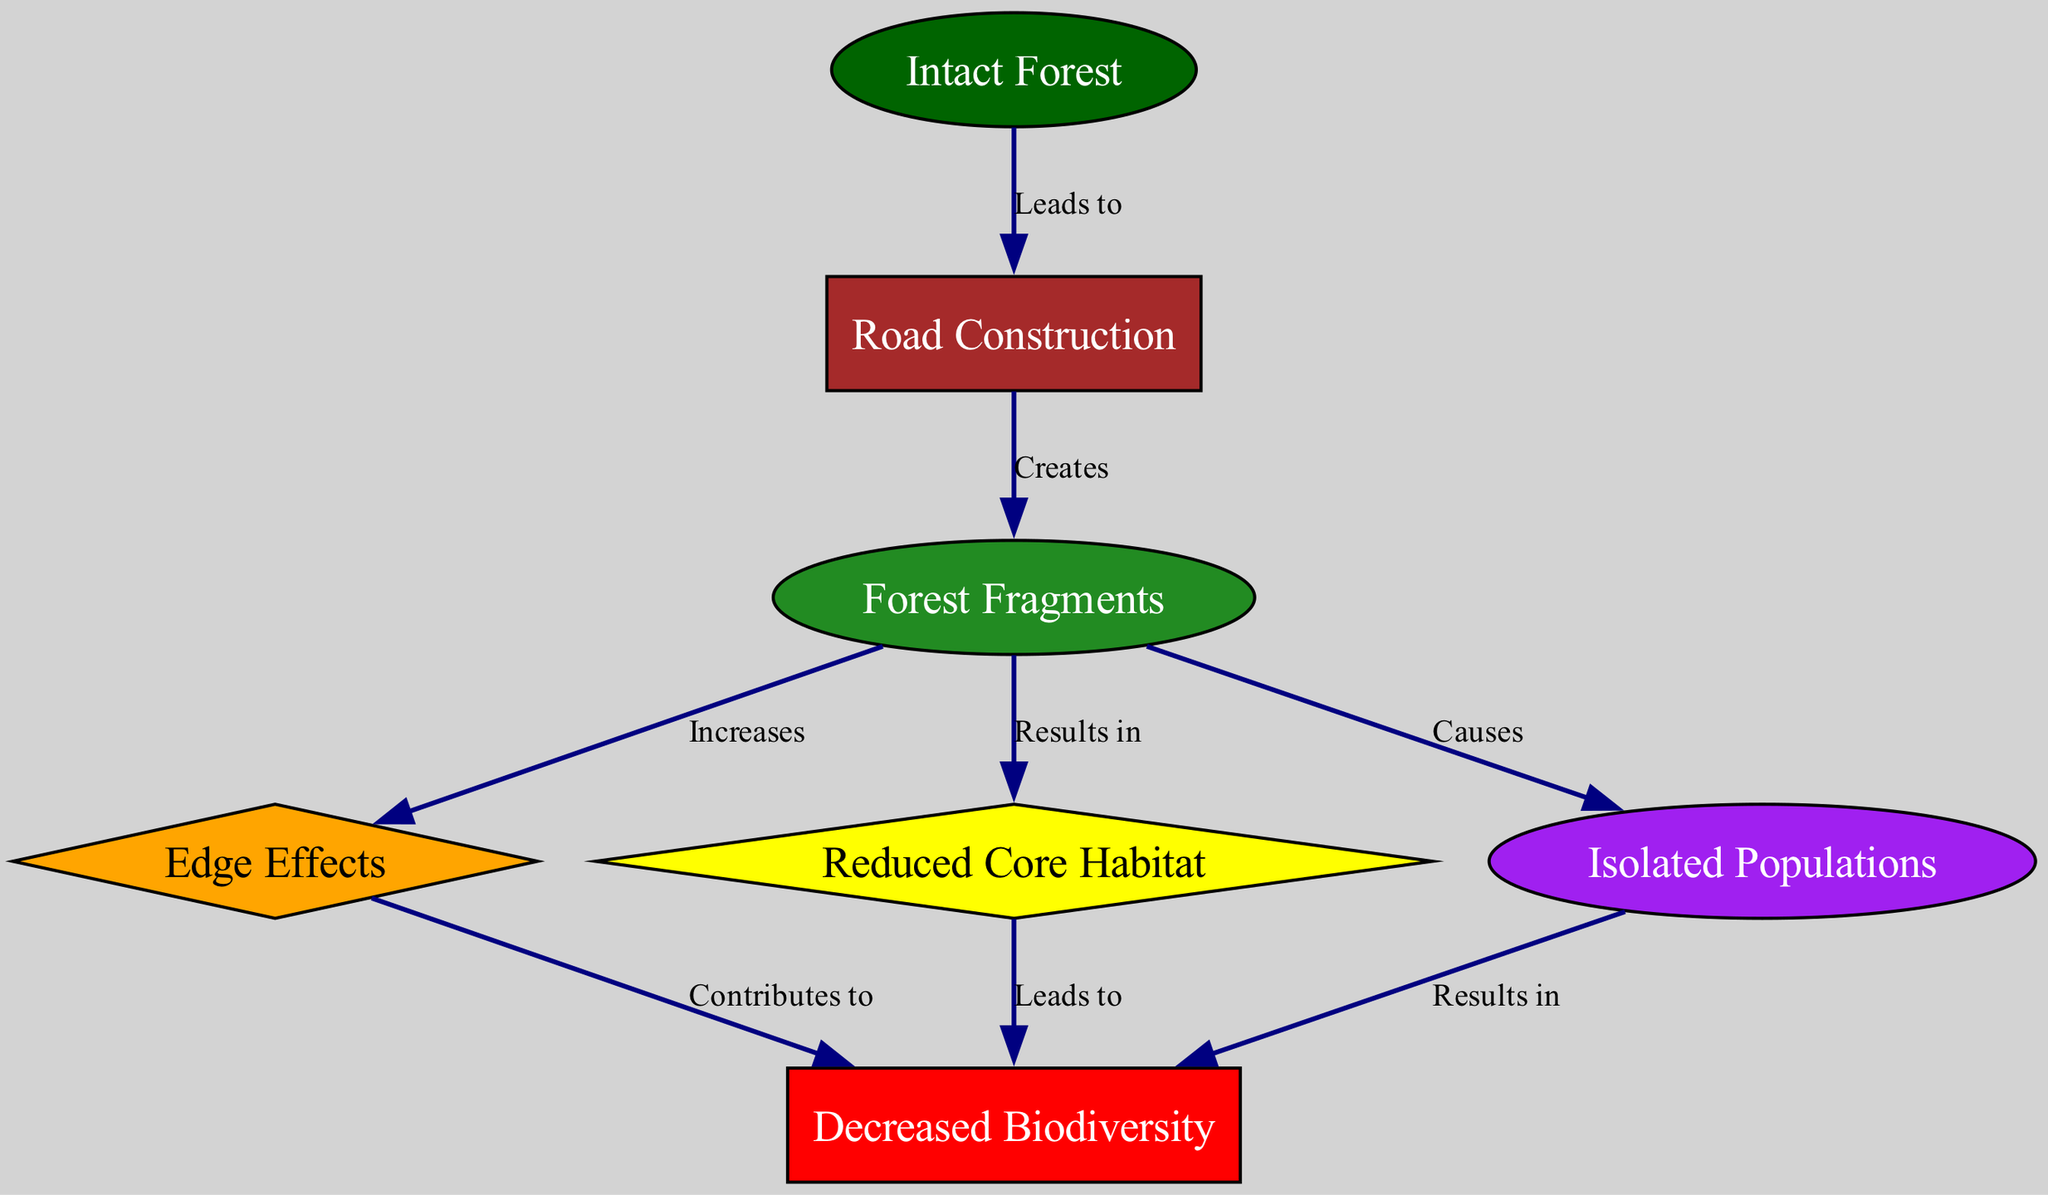What is the initial state before road construction? The diagram indicates that the initial state is represented by the node labeled "Intact Forest," which is the first node in the directed graph.
Answer: Intact Forest What does road construction create? According to the diagram, "Road Construction" leads to the creation of "Forest Fragments." This relationship is depicted by the directed edge from node 2 to node 3.
Answer: Forest Fragments How many total nodes are in the diagram? By counting the nodes represented in the diagram, there are a total of 7 nodes listed.
Answer: 7 What effect does "Forest Fragments" have on "Edge Effects"? The diagram shows that "Forest Fragments" increases "Edge Effects," indicating a direct relationship between these two concepts as depicted by the edge from node 3 to node 4.
Answer: Increases What leads to decreased biodiversity? The diagram indicates two pathways that lead to "Decreased Biodiversity": one is through "Edge Effects" contributing to it (node 4 to node 6), and the other is through "Reduced Core Habitat" also leading to it (node 5 to node 6). This shows that both edge effects and reduced habitat contribute to decreased biodiversity.
Answer: Edge Effects and Reduced Core Habitat Which node represents isolated populations? The node labeled "Isolated Populations" is represented as node 7 in the diagram.
Answer: Isolated Populations What causes isolated populations? According to the diagram, "Forest Fragments" is the node that causes "Isolated Populations," as indicated by the directed edge from node 3 to node 7.
Answer: Forest Fragments What contributes to edge effects? The diagram illustrates that "Forest Fragments" increases "Edge Effects," establishing a direct contribution from forest fragments to edge effects over the habitat.
Answer: Forest Fragments What is the final effect on biodiversity according to the diagram? The diagram shows that "Isolated Populations" result in "Decreased Biodiversity," indicating that isolation of species leads to a loss of biodiversity. This relationship is depicted by the directed edge from node 7 to node 6.
Answer: Decreased Biodiversity 